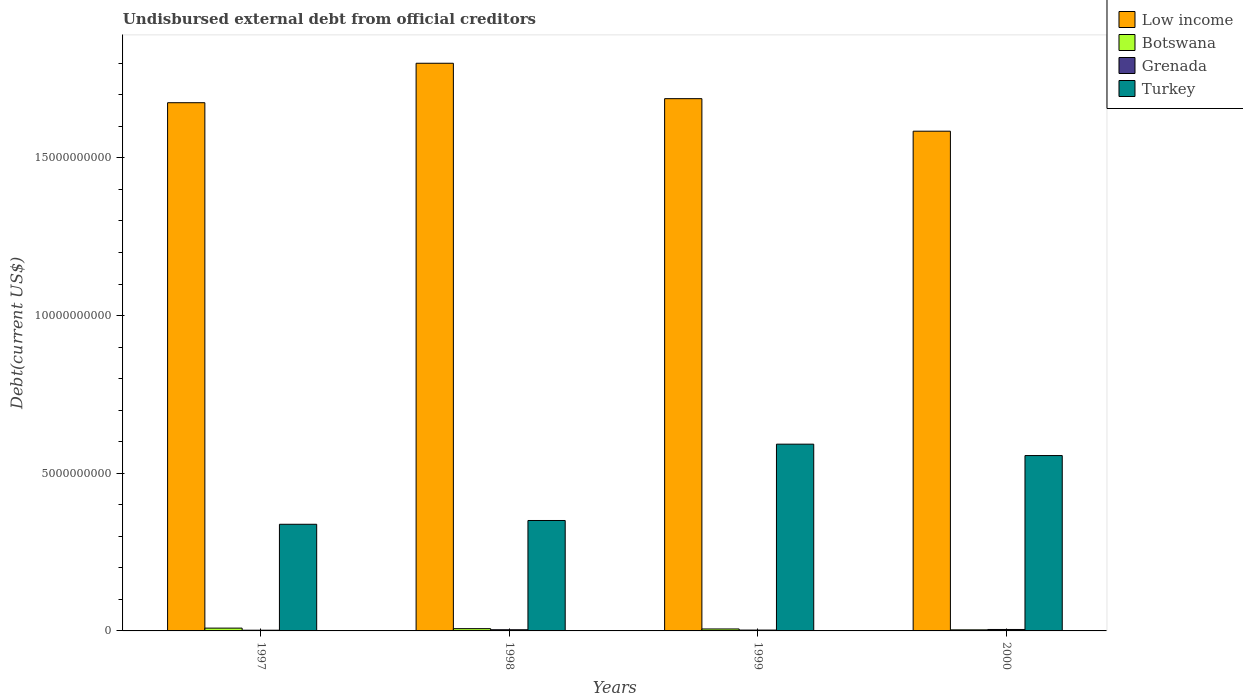How many different coloured bars are there?
Your answer should be compact. 4. How many groups of bars are there?
Ensure brevity in your answer.  4. Are the number of bars per tick equal to the number of legend labels?
Offer a very short reply. Yes. Are the number of bars on each tick of the X-axis equal?
Offer a terse response. Yes. In how many cases, is the number of bars for a given year not equal to the number of legend labels?
Your answer should be compact. 0. What is the total debt in Grenada in 1999?
Offer a very short reply. 2.69e+07. Across all years, what is the maximum total debt in Turkey?
Your answer should be compact. 5.92e+09. Across all years, what is the minimum total debt in Low income?
Offer a very short reply. 1.58e+1. In which year was the total debt in Grenada maximum?
Make the answer very short. 2000. What is the total total debt in Low income in the graph?
Provide a short and direct response. 6.75e+1. What is the difference between the total debt in Turkey in 1999 and that in 2000?
Your response must be concise. 3.61e+08. What is the difference between the total debt in Botswana in 1998 and the total debt in Low income in 1999?
Provide a succinct answer. -1.68e+1. What is the average total debt in Grenada per year?
Keep it short and to the point. 3.33e+07. In the year 1998, what is the difference between the total debt in Botswana and total debt in Turkey?
Offer a terse response. -3.43e+09. What is the ratio of the total debt in Grenada in 1998 to that in 1999?
Your response must be concise. 1.39. Is the total debt in Low income in 1998 less than that in 2000?
Give a very brief answer. No. Is the difference between the total debt in Botswana in 1997 and 2000 greater than the difference between the total debt in Turkey in 1997 and 2000?
Keep it short and to the point. Yes. What is the difference between the highest and the second highest total debt in Turkey?
Your answer should be compact. 3.61e+08. What is the difference between the highest and the lowest total debt in Turkey?
Offer a very short reply. 2.54e+09. Is the sum of the total debt in Grenada in 1997 and 1998 greater than the maximum total debt in Turkey across all years?
Your answer should be compact. No. What does the 4th bar from the left in 1999 represents?
Your response must be concise. Turkey. What does the 4th bar from the right in 1998 represents?
Provide a succinct answer. Low income. How many years are there in the graph?
Offer a very short reply. 4. What is the difference between two consecutive major ticks on the Y-axis?
Give a very brief answer. 5.00e+09. Are the values on the major ticks of Y-axis written in scientific E-notation?
Make the answer very short. No. Does the graph contain any zero values?
Keep it short and to the point. No. Does the graph contain grids?
Your answer should be very brief. No. Where does the legend appear in the graph?
Provide a succinct answer. Top right. How are the legend labels stacked?
Give a very brief answer. Vertical. What is the title of the graph?
Give a very brief answer. Undisbursed external debt from official creditors. What is the label or title of the Y-axis?
Your answer should be very brief. Debt(current US$). What is the Debt(current US$) of Low income in 1997?
Provide a succinct answer. 1.67e+1. What is the Debt(current US$) in Botswana in 1997?
Keep it short and to the point. 8.90e+07. What is the Debt(current US$) in Grenada in 1997?
Your answer should be very brief. 2.28e+07. What is the Debt(current US$) in Turkey in 1997?
Provide a short and direct response. 3.38e+09. What is the Debt(current US$) in Low income in 1998?
Give a very brief answer. 1.80e+1. What is the Debt(current US$) of Botswana in 1998?
Make the answer very short. 7.19e+07. What is the Debt(current US$) of Grenada in 1998?
Provide a succinct answer. 3.74e+07. What is the Debt(current US$) of Turkey in 1998?
Ensure brevity in your answer.  3.50e+09. What is the Debt(current US$) of Low income in 1999?
Your answer should be compact. 1.69e+1. What is the Debt(current US$) in Botswana in 1999?
Make the answer very short. 6.20e+07. What is the Debt(current US$) of Grenada in 1999?
Your response must be concise. 2.69e+07. What is the Debt(current US$) of Turkey in 1999?
Your response must be concise. 5.92e+09. What is the Debt(current US$) of Low income in 2000?
Your response must be concise. 1.58e+1. What is the Debt(current US$) in Botswana in 2000?
Make the answer very short. 3.40e+07. What is the Debt(current US$) of Grenada in 2000?
Your response must be concise. 4.60e+07. What is the Debt(current US$) in Turkey in 2000?
Provide a succinct answer. 5.56e+09. Across all years, what is the maximum Debt(current US$) in Low income?
Provide a short and direct response. 1.80e+1. Across all years, what is the maximum Debt(current US$) of Botswana?
Give a very brief answer. 8.90e+07. Across all years, what is the maximum Debt(current US$) of Grenada?
Your response must be concise. 4.60e+07. Across all years, what is the maximum Debt(current US$) of Turkey?
Keep it short and to the point. 5.92e+09. Across all years, what is the minimum Debt(current US$) of Low income?
Your answer should be very brief. 1.58e+1. Across all years, what is the minimum Debt(current US$) of Botswana?
Your response must be concise. 3.40e+07. Across all years, what is the minimum Debt(current US$) of Grenada?
Make the answer very short. 2.28e+07. Across all years, what is the minimum Debt(current US$) in Turkey?
Provide a succinct answer. 3.38e+09. What is the total Debt(current US$) of Low income in the graph?
Provide a succinct answer. 6.75e+1. What is the total Debt(current US$) in Botswana in the graph?
Make the answer very short. 2.57e+08. What is the total Debt(current US$) in Grenada in the graph?
Give a very brief answer. 1.33e+08. What is the total Debt(current US$) of Turkey in the graph?
Offer a terse response. 1.84e+1. What is the difference between the Debt(current US$) in Low income in 1997 and that in 1998?
Your answer should be very brief. -1.25e+09. What is the difference between the Debt(current US$) in Botswana in 1997 and that in 1998?
Your answer should be very brief. 1.71e+07. What is the difference between the Debt(current US$) of Grenada in 1997 and that in 1998?
Provide a short and direct response. -1.46e+07. What is the difference between the Debt(current US$) of Turkey in 1997 and that in 1998?
Provide a short and direct response. -1.20e+08. What is the difference between the Debt(current US$) of Low income in 1997 and that in 1999?
Provide a short and direct response. -1.28e+08. What is the difference between the Debt(current US$) in Botswana in 1997 and that in 1999?
Your response must be concise. 2.70e+07. What is the difference between the Debt(current US$) of Grenada in 1997 and that in 1999?
Your answer should be very brief. -4.09e+06. What is the difference between the Debt(current US$) of Turkey in 1997 and that in 1999?
Provide a short and direct response. -2.54e+09. What is the difference between the Debt(current US$) of Low income in 1997 and that in 2000?
Keep it short and to the point. 9.03e+08. What is the difference between the Debt(current US$) of Botswana in 1997 and that in 2000?
Provide a short and direct response. 5.51e+07. What is the difference between the Debt(current US$) in Grenada in 1997 and that in 2000?
Offer a terse response. -2.32e+07. What is the difference between the Debt(current US$) in Turkey in 1997 and that in 2000?
Provide a short and direct response. -2.18e+09. What is the difference between the Debt(current US$) in Low income in 1998 and that in 1999?
Provide a short and direct response. 1.12e+09. What is the difference between the Debt(current US$) of Botswana in 1998 and that in 1999?
Give a very brief answer. 9.93e+06. What is the difference between the Debt(current US$) in Grenada in 1998 and that in 1999?
Offer a terse response. 1.05e+07. What is the difference between the Debt(current US$) in Turkey in 1998 and that in 1999?
Give a very brief answer. -2.42e+09. What is the difference between the Debt(current US$) in Low income in 1998 and that in 2000?
Keep it short and to the point. 2.15e+09. What is the difference between the Debt(current US$) of Botswana in 1998 and that in 2000?
Provide a short and direct response. 3.80e+07. What is the difference between the Debt(current US$) in Grenada in 1998 and that in 2000?
Offer a terse response. -8.59e+06. What is the difference between the Debt(current US$) of Turkey in 1998 and that in 2000?
Give a very brief answer. -2.06e+09. What is the difference between the Debt(current US$) in Low income in 1999 and that in 2000?
Provide a short and direct response. 1.03e+09. What is the difference between the Debt(current US$) in Botswana in 1999 and that in 2000?
Offer a terse response. 2.80e+07. What is the difference between the Debt(current US$) of Grenada in 1999 and that in 2000?
Provide a short and direct response. -1.91e+07. What is the difference between the Debt(current US$) of Turkey in 1999 and that in 2000?
Offer a terse response. 3.61e+08. What is the difference between the Debt(current US$) of Low income in 1997 and the Debt(current US$) of Botswana in 1998?
Make the answer very short. 1.67e+1. What is the difference between the Debt(current US$) in Low income in 1997 and the Debt(current US$) in Grenada in 1998?
Your answer should be compact. 1.67e+1. What is the difference between the Debt(current US$) in Low income in 1997 and the Debt(current US$) in Turkey in 1998?
Offer a terse response. 1.32e+1. What is the difference between the Debt(current US$) in Botswana in 1997 and the Debt(current US$) in Grenada in 1998?
Make the answer very short. 5.16e+07. What is the difference between the Debt(current US$) in Botswana in 1997 and the Debt(current US$) in Turkey in 1998?
Offer a terse response. -3.41e+09. What is the difference between the Debt(current US$) of Grenada in 1997 and the Debt(current US$) of Turkey in 1998?
Provide a succinct answer. -3.48e+09. What is the difference between the Debt(current US$) in Low income in 1997 and the Debt(current US$) in Botswana in 1999?
Give a very brief answer. 1.67e+1. What is the difference between the Debt(current US$) of Low income in 1997 and the Debt(current US$) of Grenada in 1999?
Keep it short and to the point. 1.67e+1. What is the difference between the Debt(current US$) in Low income in 1997 and the Debt(current US$) in Turkey in 1999?
Ensure brevity in your answer.  1.08e+1. What is the difference between the Debt(current US$) in Botswana in 1997 and the Debt(current US$) in Grenada in 1999?
Your response must be concise. 6.22e+07. What is the difference between the Debt(current US$) in Botswana in 1997 and the Debt(current US$) in Turkey in 1999?
Give a very brief answer. -5.83e+09. What is the difference between the Debt(current US$) of Grenada in 1997 and the Debt(current US$) of Turkey in 1999?
Give a very brief answer. -5.90e+09. What is the difference between the Debt(current US$) in Low income in 1997 and the Debt(current US$) in Botswana in 2000?
Your response must be concise. 1.67e+1. What is the difference between the Debt(current US$) of Low income in 1997 and the Debt(current US$) of Grenada in 2000?
Ensure brevity in your answer.  1.67e+1. What is the difference between the Debt(current US$) in Low income in 1997 and the Debt(current US$) in Turkey in 2000?
Your answer should be very brief. 1.12e+1. What is the difference between the Debt(current US$) of Botswana in 1997 and the Debt(current US$) of Grenada in 2000?
Your response must be concise. 4.30e+07. What is the difference between the Debt(current US$) of Botswana in 1997 and the Debt(current US$) of Turkey in 2000?
Your answer should be very brief. -5.47e+09. What is the difference between the Debt(current US$) of Grenada in 1997 and the Debt(current US$) of Turkey in 2000?
Offer a terse response. -5.54e+09. What is the difference between the Debt(current US$) in Low income in 1998 and the Debt(current US$) in Botswana in 1999?
Your response must be concise. 1.79e+1. What is the difference between the Debt(current US$) of Low income in 1998 and the Debt(current US$) of Grenada in 1999?
Your answer should be compact. 1.80e+1. What is the difference between the Debt(current US$) of Low income in 1998 and the Debt(current US$) of Turkey in 1999?
Provide a succinct answer. 1.21e+1. What is the difference between the Debt(current US$) in Botswana in 1998 and the Debt(current US$) in Grenada in 1999?
Your answer should be very brief. 4.51e+07. What is the difference between the Debt(current US$) in Botswana in 1998 and the Debt(current US$) in Turkey in 1999?
Provide a short and direct response. -5.85e+09. What is the difference between the Debt(current US$) of Grenada in 1998 and the Debt(current US$) of Turkey in 1999?
Ensure brevity in your answer.  -5.88e+09. What is the difference between the Debt(current US$) in Low income in 1998 and the Debt(current US$) in Botswana in 2000?
Offer a very short reply. 1.80e+1. What is the difference between the Debt(current US$) of Low income in 1998 and the Debt(current US$) of Grenada in 2000?
Give a very brief answer. 1.80e+1. What is the difference between the Debt(current US$) of Low income in 1998 and the Debt(current US$) of Turkey in 2000?
Offer a terse response. 1.24e+1. What is the difference between the Debt(current US$) of Botswana in 1998 and the Debt(current US$) of Grenada in 2000?
Your response must be concise. 2.59e+07. What is the difference between the Debt(current US$) in Botswana in 1998 and the Debt(current US$) in Turkey in 2000?
Provide a succinct answer. -5.49e+09. What is the difference between the Debt(current US$) in Grenada in 1998 and the Debt(current US$) in Turkey in 2000?
Ensure brevity in your answer.  -5.52e+09. What is the difference between the Debt(current US$) of Low income in 1999 and the Debt(current US$) of Botswana in 2000?
Keep it short and to the point. 1.68e+1. What is the difference between the Debt(current US$) of Low income in 1999 and the Debt(current US$) of Grenada in 2000?
Ensure brevity in your answer.  1.68e+1. What is the difference between the Debt(current US$) of Low income in 1999 and the Debt(current US$) of Turkey in 2000?
Provide a succinct answer. 1.13e+1. What is the difference between the Debt(current US$) of Botswana in 1999 and the Debt(current US$) of Grenada in 2000?
Keep it short and to the point. 1.60e+07. What is the difference between the Debt(current US$) in Botswana in 1999 and the Debt(current US$) in Turkey in 2000?
Ensure brevity in your answer.  -5.50e+09. What is the difference between the Debt(current US$) of Grenada in 1999 and the Debt(current US$) of Turkey in 2000?
Provide a short and direct response. -5.53e+09. What is the average Debt(current US$) in Low income per year?
Give a very brief answer. 1.69e+1. What is the average Debt(current US$) in Botswana per year?
Ensure brevity in your answer.  6.42e+07. What is the average Debt(current US$) in Grenada per year?
Ensure brevity in your answer.  3.33e+07. What is the average Debt(current US$) in Turkey per year?
Provide a short and direct response. 4.59e+09. In the year 1997, what is the difference between the Debt(current US$) of Low income and Debt(current US$) of Botswana?
Provide a short and direct response. 1.67e+1. In the year 1997, what is the difference between the Debt(current US$) of Low income and Debt(current US$) of Grenada?
Your answer should be compact. 1.67e+1. In the year 1997, what is the difference between the Debt(current US$) of Low income and Debt(current US$) of Turkey?
Offer a very short reply. 1.34e+1. In the year 1997, what is the difference between the Debt(current US$) in Botswana and Debt(current US$) in Grenada?
Ensure brevity in your answer.  6.63e+07. In the year 1997, what is the difference between the Debt(current US$) of Botswana and Debt(current US$) of Turkey?
Keep it short and to the point. -3.29e+09. In the year 1997, what is the difference between the Debt(current US$) of Grenada and Debt(current US$) of Turkey?
Ensure brevity in your answer.  -3.36e+09. In the year 1998, what is the difference between the Debt(current US$) in Low income and Debt(current US$) in Botswana?
Your response must be concise. 1.79e+1. In the year 1998, what is the difference between the Debt(current US$) of Low income and Debt(current US$) of Grenada?
Keep it short and to the point. 1.80e+1. In the year 1998, what is the difference between the Debt(current US$) in Low income and Debt(current US$) in Turkey?
Give a very brief answer. 1.45e+1. In the year 1998, what is the difference between the Debt(current US$) of Botswana and Debt(current US$) of Grenada?
Offer a terse response. 3.45e+07. In the year 1998, what is the difference between the Debt(current US$) of Botswana and Debt(current US$) of Turkey?
Your response must be concise. -3.43e+09. In the year 1998, what is the difference between the Debt(current US$) of Grenada and Debt(current US$) of Turkey?
Give a very brief answer. -3.46e+09. In the year 1999, what is the difference between the Debt(current US$) of Low income and Debt(current US$) of Botswana?
Your answer should be compact. 1.68e+1. In the year 1999, what is the difference between the Debt(current US$) of Low income and Debt(current US$) of Grenada?
Ensure brevity in your answer.  1.68e+1. In the year 1999, what is the difference between the Debt(current US$) in Low income and Debt(current US$) in Turkey?
Your answer should be very brief. 1.10e+1. In the year 1999, what is the difference between the Debt(current US$) of Botswana and Debt(current US$) of Grenada?
Provide a succinct answer. 3.51e+07. In the year 1999, what is the difference between the Debt(current US$) of Botswana and Debt(current US$) of Turkey?
Offer a very short reply. -5.86e+09. In the year 1999, what is the difference between the Debt(current US$) of Grenada and Debt(current US$) of Turkey?
Your answer should be compact. -5.89e+09. In the year 2000, what is the difference between the Debt(current US$) of Low income and Debt(current US$) of Botswana?
Your response must be concise. 1.58e+1. In the year 2000, what is the difference between the Debt(current US$) in Low income and Debt(current US$) in Grenada?
Provide a succinct answer. 1.58e+1. In the year 2000, what is the difference between the Debt(current US$) in Low income and Debt(current US$) in Turkey?
Provide a succinct answer. 1.03e+1. In the year 2000, what is the difference between the Debt(current US$) in Botswana and Debt(current US$) in Grenada?
Give a very brief answer. -1.20e+07. In the year 2000, what is the difference between the Debt(current US$) in Botswana and Debt(current US$) in Turkey?
Make the answer very short. -5.53e+09. In the year 2000, what is the difference between the Debt(current US$) in Grenada and Debt(current US$) in Turkey?
Keep it short and to the point. -5.51e+09. What is the ratio of the Debt(current US$) of Low income in 1997 to that in 1998?
Your answer should be very brief. 0.93. What is the ratio of the Debt(current US$) of Botswana in 1997 to that in 1998?
Your response must be concise. 1.24. What is the ratio of the Debt(current US$) of Grenada in 1997 to that in 1998?
Keep it short and to the point. 0.61. What is the ratio of the Debt(current US$) in Turkey in 1997 to that in 1998?
Offer a very short reply. 0.97. What is the ratio of the Debt(current US$) of Low income in 1997 to that in 1999?
Your response must be concise. 0.99. What is the ratio of the Debt(current US$) of Botswana in 1997 to that in 1999?
Your answer should be very brief. 1.44. What is the ratio of the Debt(current US$) of Grenada in 1997 to that in 1999?
Offer a very short reply. 0.85. What is the ratio of the Debt(current US$) of Turkey in 1997 to that in 1999?
Provide a short and direct response. 0.57. What is the ratio of the Debt(current US$) of Low income in 1997 to that in 2000?
Offer a terse response. 1.06. What is the ratio of the Debt(current US$) in Botswana in 1997 to that in 2000?
Provide a short and direct response. 2.62. What is the ratio of the Debt(current US$) in Grenada in 1997 to that in 2000?
Your answer should be very brief. 0.5. What is the ratio of the Debt(current US$) in Turkey in 1997 to that in 2000?
Give a very brief answer. 0.61. What is the ratio of the Debt(current US$) in Low income in 1998 to that in 1999?
Offer a very short reply. 1.07. What is the ratio of the Debt(current US$) in Botswana in 1998 to that in 1999?
Provide a succinct answer. 1.16. What is the ratio of the Debt(current US$) in Grenada in 1998 to that in 1999?
Make the answer very short. 1.39. What is the ratio of the Debt(current US$) of Turkey in 1998 to that in 1999?
Offer a terse response. 0.59. What is the ratio of the Debt(current US$) of Low income in 1998 to that in 2000?
Make the answer very short. 1.14. What is the ratio of the Debt(current US$) in Botswana in 1998 to that in 2000?
Provide a succinct answer. 2.12. What is the ratio of the Debt(current US$) of Grenada in 1998 to that in 2000?
Offer a very short reply. 0.81. What is the ratio of the Debt(current US$) of Turkey in 1998 to that in 2000?
Offer a very short reply. 0.63. What is the ratio of the Debt(current US$) of Low income in 1999 to that in 2000?
Make the answer very short. 1.07. What is the ratio of the Debt(current US$) in Botswana in 1999 to that in 2000?
Make the answer very short. 1.82. What is the ratio of the Debt(current US$) of Grenada in 1999 to that in 2000?
Provide a short and direct response. 0.58. What is the ratio of the Debt(current US$) in Turkey in 1999 to that in 2000?
Keep it short and to the point. 1.06. What is the difference between the highest and the second highest Debt(current US$) in Low income?
Offer a very short reply. 1.12e+09. What is the difference between the highest and the second highest Debt(current US$) in Botswana?
Ensure brevity in your answer.  1.71e+07. What is the difference between the highest and the second highest Debt(current US$) in Grenada?
Keep it short and to the point. 8.59e+06. What is the difference between the highest and the second highest Debt(current US$) of Turkey?
Your answer should be compact. 3.61e+08. What is the difference between the highest and the lowest Debt(current US$) of Low income?
Make the answer very short. 2.15e+09. What is the difference between the highest and the lowest Debt(current US$) of Botswana?
Give a very brief answer. 5.51e+07. What is the difference between the highest and the lowest Debt(current US$) of Grenada?
Ensure brevity in your answer.  2.32e+07. What is the difference between the highest and the lowest Debt(current US$) in Turkey?
Your answer should be very brief. 2.54e+09. 